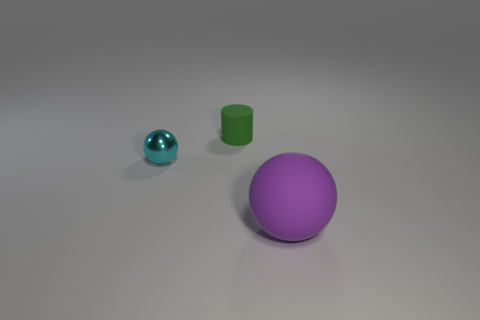Is there anything else that is the same material as the small sphere?
Your response must be concise. No. There is another big thing that is the same shape as the cyan metal thing; what material is it?
Provide a succinct answer. Rubber. How many other things are the same material as the tiny cylinder?
Ensure brevity in your answer.  1. The object in front of the thing that is to the left of the thing that is behind the tiny cyan shiny thing is what shape?
Give a very brief answer. Sphere. Does the sphere on the right side of the matte cylinder have the same material as the object that is on the left side of the tiny cylinder?
Keep it short and to the point. No. What is the tiny cyan thing made of?
Your response must be concise. Metal. How many other things have the same shape as the big rubber object?
Your answer should be very brief. 1. Are there any other things that are the same shape as the cyan metallic thing?
Keep it short and to the point. Yes. What color is the tiny object in front of the rubber object that is behind the small thing in front of the green rubber object?
Offer a very short reply. Cyan. How many tiny things are matte spheres or yellow rubber spheres?
Make the answer very short. 0. 